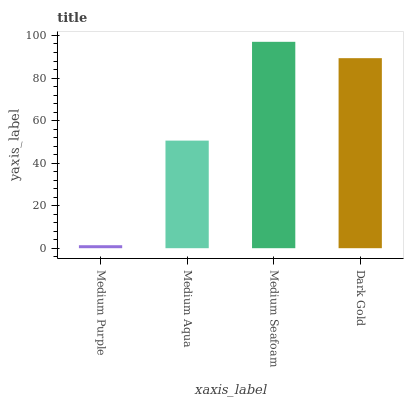Is Medium Purple the minimum?
Answer yes or no. Yes. Is Medium Seafoam the maximum?
Answer yes or no. Yes. Is Medium Aqua the minimum?
Answer yes or no. No. Is Medium Aqua the maximum?
Answer yes or no. No. Is Medium Aqua greater than Medium Purple?
Answer yes or no. Yes. Is Medium Purple less than Medium Aqua?
Answer yes or no. Yes. Is Medium Purple greater than Medium Aqua?
Answer yes or no. No. Is Medium Aqua less than Medium Purple?
Answer yes or no. No. Is Dark Gold the high median?
Answer yes or no. Yes. Is Medium Aqua the low median?
Answer yes or no. Yes. Is Medium Purple the high median?
Answer yes or no. No. Is Medium Seafoam the low median?
Answer yes or no. No. 